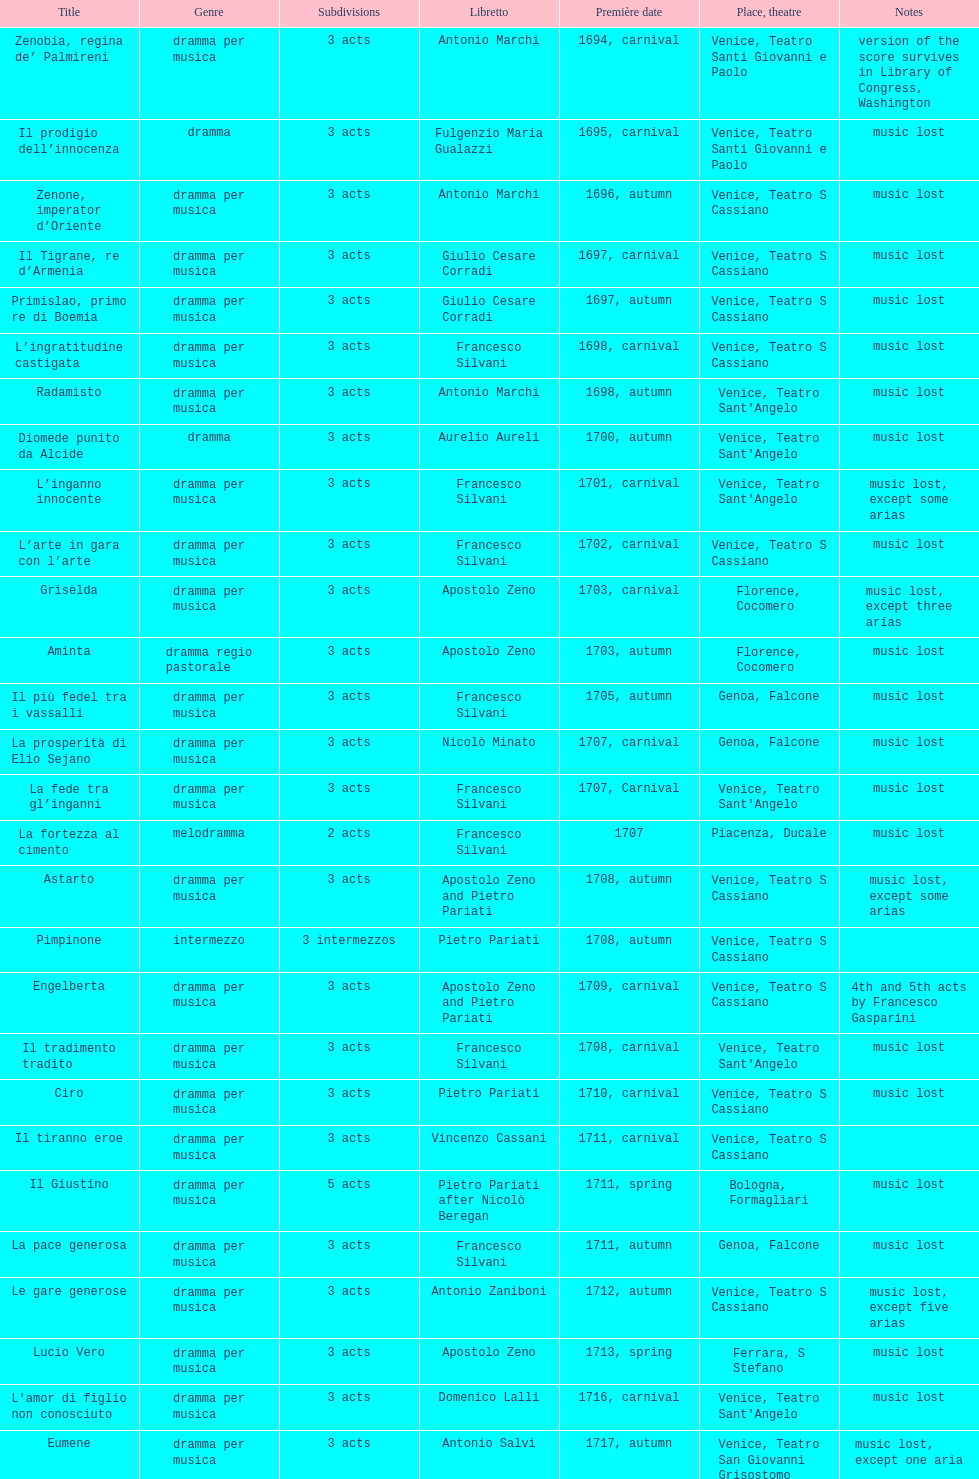Which opera has the most acts, la fortezza al cimento or astarto? Astarto. 